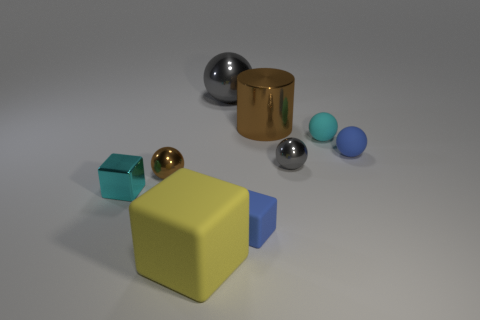Subtract all yellow blocks. How many gray spheres are left? 2 Subtract all small spheres. How many spheres are left? 1 Subtract all brown balls. How many balls are left? 4 Subtract all yellow balls. Subtract all blue cylinders. How many balls are left? 5 Add 1 small gray metallic spheres. How many objects exist? 10 Subtract all cylinders. How many objects are left? 8 Subtract 0 red balls. How many objects are left? 9 Subtract all tiny purple rubber spheres. Subtract all cyan blocks. How many objects are left? 8 Add 4 small cubes. How many small cubes are left? 6 Add 8 large metallic things. How many large metallic things exist? 10 